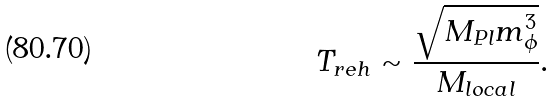<formula> <loc_0><loc_0><loc_500><loc_500>T _ { r e h } \sim \frac { \sqrt { M _ { P l } m _ { \phi } ^ { 3 } } } { M _ { l o c a l } } .</formula> 